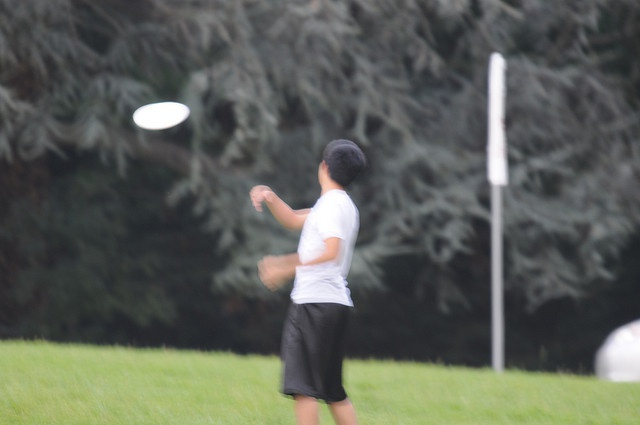Describe the objects in this image and their specific colors. I can see people in black, lavender, gray, and tan tones and frisbee in black, white, darkgray, and gray tones in this image. 